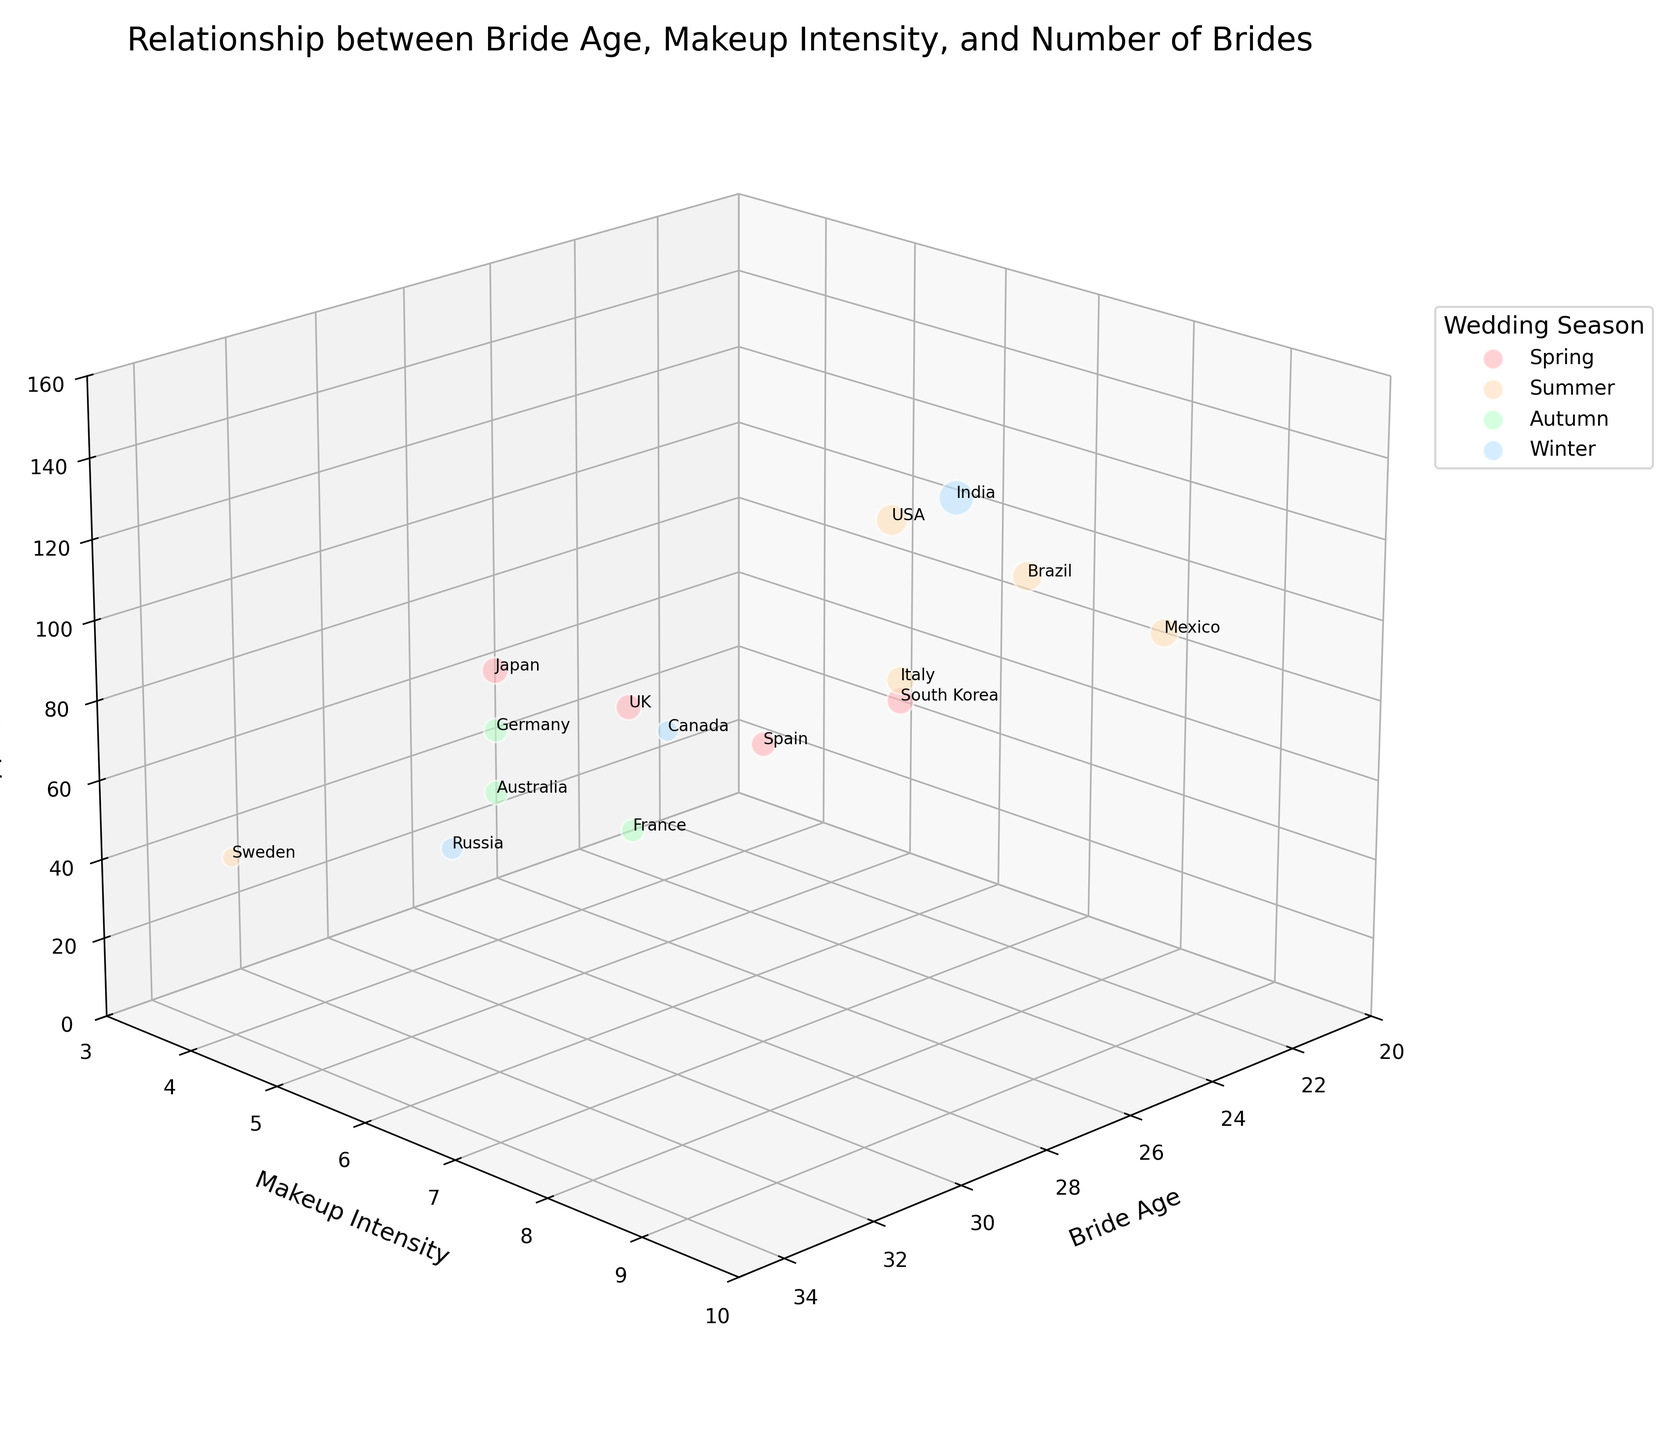What's the range of bride ages represented in the chart? The chart shows ages on the x-axis, starting from the youngest age at 23 (Mexico) and going up to the oldest age at 34 (Sweden)
Answer: 23 to 34 Which country has the highest makeup intensity, and what season is their wedding? The z-axis indicates makeup intensity, with India and Mexico both having the highest intensity of 9. According to the colors, India’s season is Winter, and Mexico’s is Summer
Answer: India (Winter) and Mexico (Summer) What is the predominant wedding season represented in the chart? By counting the data points labeled with colors corresponding to each season (pink for Spring, orange for Summer, green for Autumn, blue for Winter), Summer appears most frequently
Answer: Summer Which country has the youngest brides, and what is their makeup intensity? By examining the x-axis for the youngest bride age of 23, it corresponds to Mexico, and the associated makeup intensity on the y-axis is 9
Answer: Mexico, 9 What is the average makeup intensity for brides aged 27? For the brides aged 27 (Italy and South Korea), their makeup intensities are 8 each. (8 + 8) / 2 = 8
Answer: 8 Which seasons are represented in the countries with the top two highest numbers of brides? By viewing the z-axis, the highest numbers of brides are India (150) and USA (120). The colors indicate Winter for India and Summer for USA
Answer: Winter and Summer Comparing Germany and France, which has more brides, and by how many? The z-axis values show Germany with 70 brides and France with 65 brides. Subtracting gives 70 - 65 = 5
Answer: Germany, by 5 What is the makeup intensity and age for the brides representing Sweden? Locate Sweden on the x-axis at age 34. The y-axis shows the makeup intensity at 4, and the z-axis shows the number of brides at 45
Answer: 4, 34 Sort the countries by bride age in ascending order and identify the top two. By examining the x-axis values, they increase in this order: Mexico (23), Brazil (24), USA (25). Mexico and Brazil are the top two.
Answer: Mexico and Brazil Is there a trend in makeup intensity across different seasons? Do brides tend to use more makeup during specific seasons? Reviewing the makeup intensity values (y-axis) and wedding seasons (color codes), Winter has a range of 5 to 9, Spring 5 to 8, Summer 7 to 9, and Autumn 5 to 7. No definitive season stands out with drastic differences.
Answer: No clear trend 